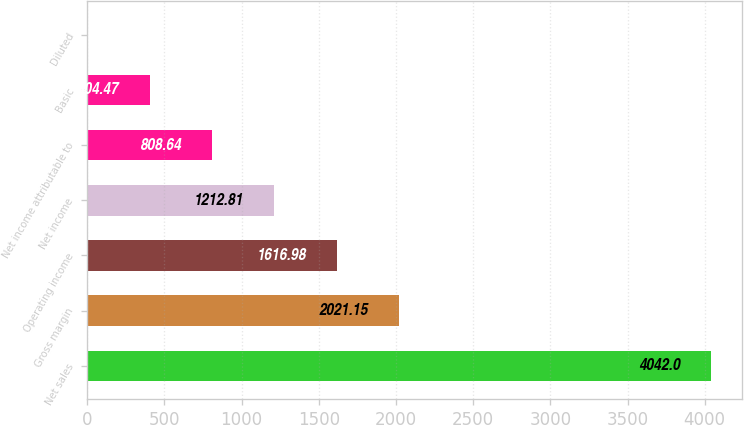<chart> <loc_0><loc_0><loc_500><loc_500><bar_chart><fcel>Net sales<fcel>Gross margin<fcel>Operating income<fcel>Net income<fcel>Net income attributable to<fcel>Basic<fcel>Diluted<nl><fcel>4042<fcel>2021.15<fcel>1616.98<fcel>1212.81<fcel>808.64<fcel>404.47<fcel>0.3<nl></chart> 